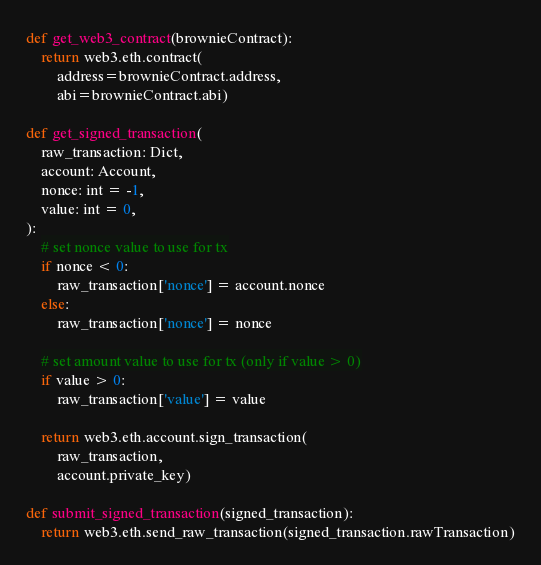<code> <loc_0><loc_0><loc_500><loc_500><_Python_>
def get_web3_contract(brownieContract):
    return web3.eth.contract(
        address=brownieContract.address, 
        abi=brownieContract.abi)

def get_signed_transaction(
    raw_transaction: Dict, 
    account: Account, 
    nonce: int = -1,
    value: int = 0,
):
    # set nonce value to use for tx
    if nonce < 0:
        raw_transaction['nonce'] = account.nonce
    else:
        raw_transaction['nonce'] = nonce

    # set amount value to use for tx (only if value > 0)
    if value > 0:
        raw_transaction['value'] = value

    return web3.eth.account.sign_transaction(
        raw_transaction, 
        account.private_key)

def submit_signed_transaction(signed_transaction):
    return web3.eth.send_raw_transaction(signed_transaction.rawTransaction)</code> 